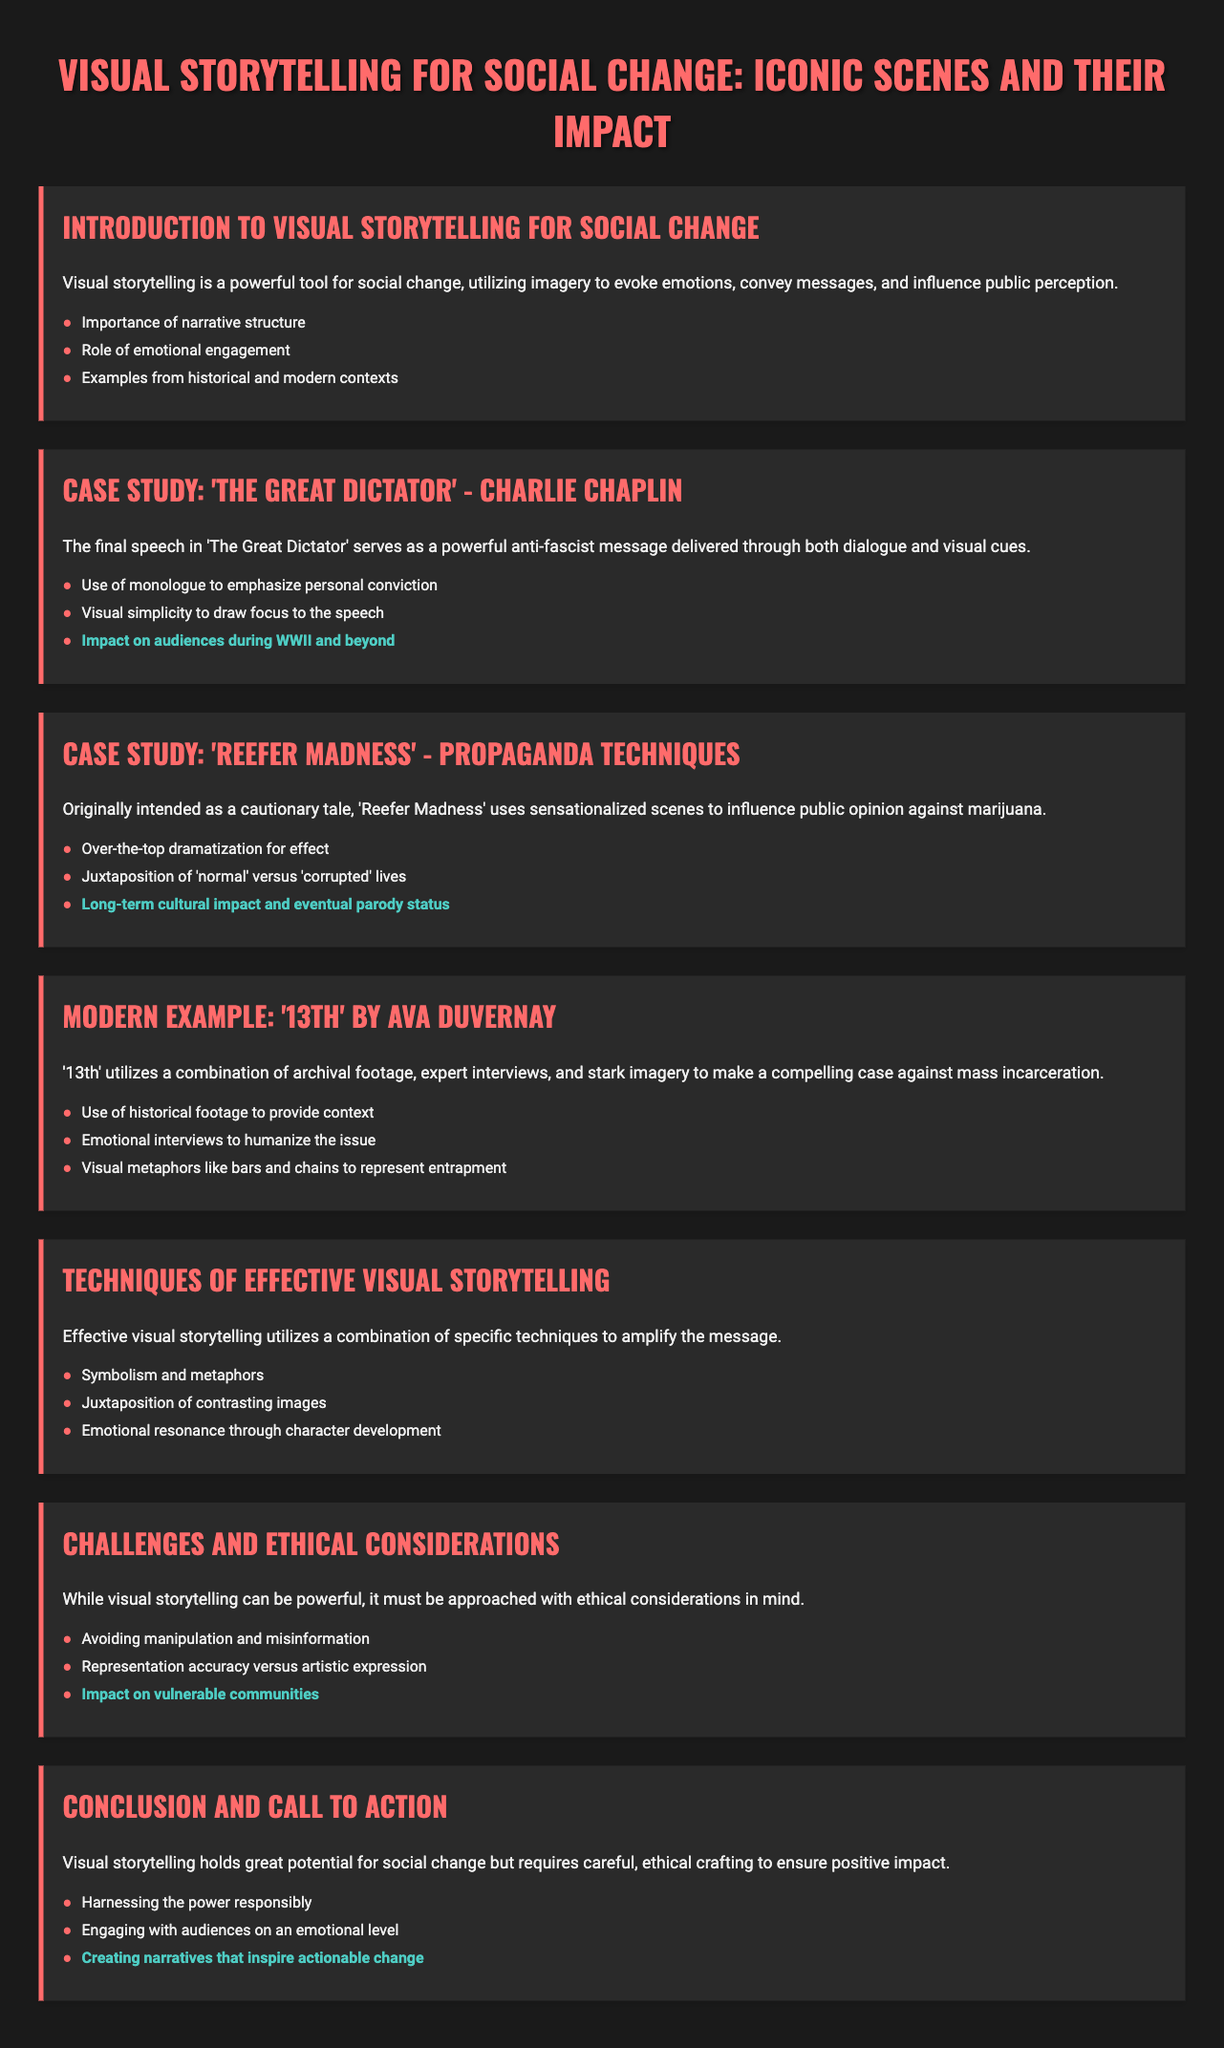What is the title of the presentation? The title of the presentation is prominently displayed at the top of the document.
Answer: Visual Storytelling for Social Change: Iconic Scenes and Their Impact What film does the case study focus on in the second slide? The second slide highlights a case study that discusses a specific film known for its anti-fascist message.
Answer: The Great Dictator What technique is used in 'Reefer Madness' according to the document? 'Reefer Madness' is mentioned to utilize specific techniques in its storytelling approach.
Answer: Sensationalized scenes What is the primary focus of the documentary '13th' by Ava DuVernay? The slide discussing '13th' elucidates its core argument against a specific issue in society.
Answer: Mass incarceration What is one ethical consideration mentioned in the presentation? The document lists various ethical considerations that should be taken into account in visual storytelling.
Answer: Avoiding manipulation What impact did 'The Great Dictator' have on audiences during a specific historical period? The slide about ‘The Great Dictator’ notes its reception in relation to a significant global event.
Answer: WWII and beyond How does effective visual storytelling amplify its message? The techniques listed in the slide contribute to the effectiveness of visual storytelling in making a larger impact.
Answer: Combination of specific techniques What is a narrative structure mentioned in the introduction slide? The introduction lists key elements of effective visual storytelling, including its foundational aspect.
Answer: Importance of narrative structure What is highlighted as a key outcome of visual storytelling in the conclusion? The last slide stresses the ultimate goal of visual storytelling for social change.
Answer: Creating narratives that inspire actionable change 